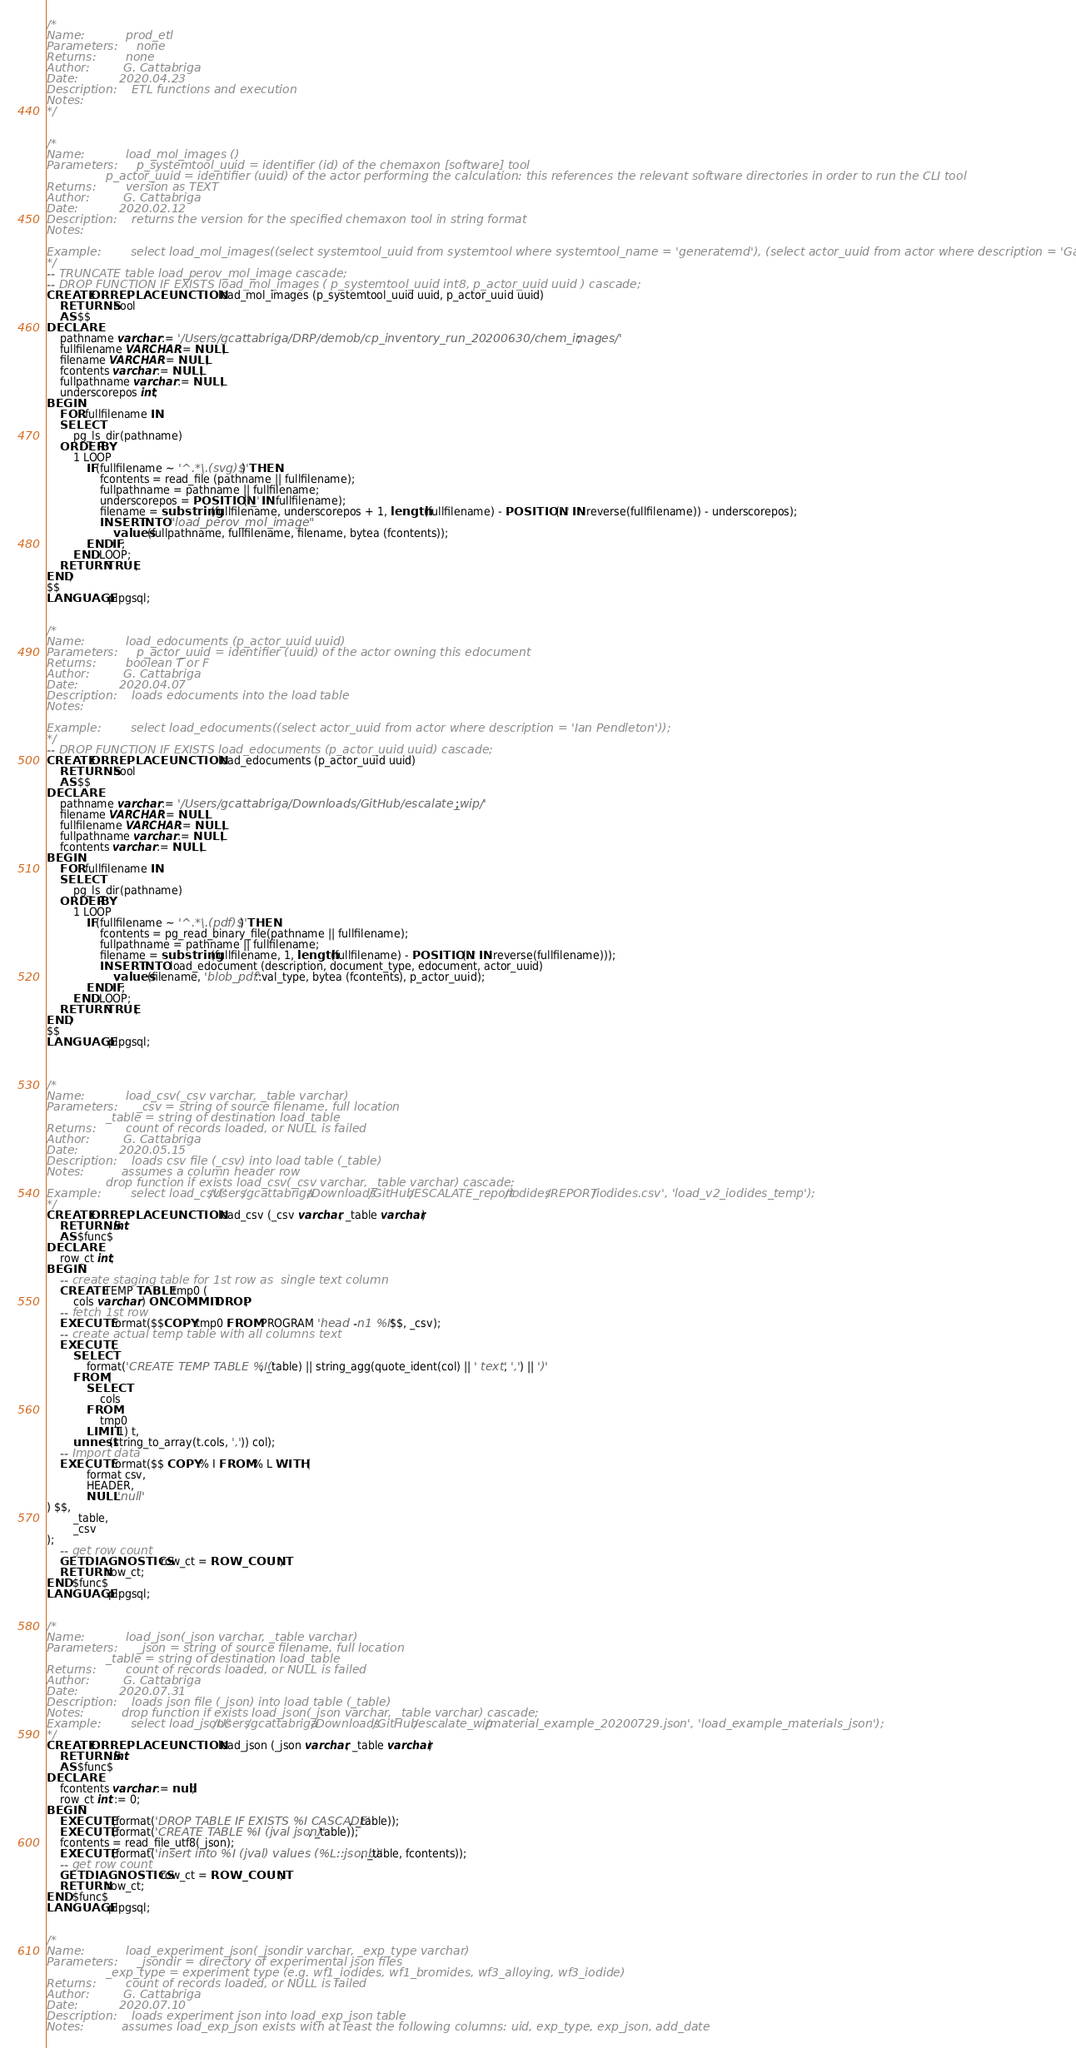Convert code to text. <code><loc_0><loc_0><loc_500><loc_500><_SQL_>/*
Name:			prod_etl
Parameters:		none
Returns:		none
Author:			G. Cattabriga
Date:			2020.04.23
Description:	ETL functions and execution
Notes:											
*/


/*
Name:			load_mol_images ()
Parameters:		p_systemtool_uuid = identifier (id) of the chemaxon [software] tool
				p_actor_uuid = identifier (uuid) of the actor performing the calculation: this references the relevant software directories in order to run the CLI tool
Returns:		version as TEXT
Author:			G. Cattabriga
Date:			2020.02.12
Description:	returns the version for the specified chemaxon tool in string format 
Notes:				
							
Example:		select load_mol_images((select systemtool_uuid from systemtool where systemtool_name = 'generatemd'), (select actor_uuid from actor where description = 'Gary Cattabriga'));
*/
-- TRUNCATE table load_perov_mol_image cascade;
-- DROP FUNCTION IF EXISTS load_mol_images ( p_systemtool_uuid int8, p_actor_uuid uuid ) cascade;
CREATE OR REPLACE FUNCTION load_mol_images (p_systemtool_uuid uuid, p_actor_uuid uuid)
	RETURNS bool
	AS $$
DECLARE
	pathname varchar := '/Users/gcattabriga/DRP/demob/cp_inventory_run_20200630/chem_images/';
	fullfilename VARCHAR := NULL;
	filename VARCHAR := NULL;
	fcontents varchar := NULL;
	fullpathname varchar := NULL;
	underscorepos int;
BEGIN
	FOR fullfilename IN
	SELECT
		pg_ls_dir(pathname)
	ORDER BY
		1 LOOP
			IF(fullfilename ~ '^.*\.(svg)$') THEN
				fcontents = read_file (pathname || fullfilename);
				fullpathname = pathname || fullfilename;
				underscorepos = POSITION('_' IN fullfilename);
				filename = substring(fullfilename, underscorepos + 1, length(fullfilename) - POSITION('.' IN reverse(fullfilename)) - underscorepos);
				INSERT INTO "load_perov_mol_image"
					values(fullpathname, fullfilename, filename, bytea (fcontents));
			END IF;
		END LOOP;
	RETURN TRUE;
END;
$$
LANGUAGE plpgsql;


/*
Name:			load_edocuments (p_actor_uuid uuid)
Parameters:		p_actor_uuid = identifier (uuid) of the actor owning this edocument
Returns:		boolean T or F
Author:			G. Cattabriga
Date:			2020.04.07
Description:	loads edocuments into the load table 
Notes:				
							
Example:		select load_edocuments((select actor_uuid from actor where description = 'Ian Pendleton'));
*/
-- DROP FUNCTION IF EXISTS load_edocuments (p_actor_uuid uuid) cascade;
CREATE OR REPLACE FUNCTION load_edocuments (p_actor_uuid uuid)
	RETURNS bool
	AS $$
DECLARE
	pathname varchar := '/Users/gcattabriga/Downloads/GitHub/escalate_wip/';
	filename VARCHAR := NULL;
	fullfilename VARCHAR := NULL;
	fullpathname varchar := NULL;
	fcontents varchar := NULL;
BEGIN
	FOR fullfilename IN
	SELECT
		pg_ls_dir(pathname)
	ORDER BY
		1 LOOP
			IF(fullfilename ~ '^.*\.(pdf)$') THEN
				fcontents = pg_read_binary_file(pathname || fullfilename);
				fullpathname = pathname || fullfilename;
				filename = substring(fullfilename, 1, length(fullfilename) - POSITION('.' IN reverse(fullfilename)));
				INSERT INTO load_edocument (description, document_type, edocument, actor_uuid)
					values(filename, 'blob_pdf'::val_type, bytea (fcontents), p_actor_uuid);
			END IF;
		END LOOP;
	RETURN TRUE;
END;
$$
LANGUAGE plpgsql;



/*
Name:			load_csv(_csv varchar, _table varchar)
Parameters:		_csv = string of source filename, full location
				_table = string of destination load_table
Returns:		count of records loaded, or NULL is failed
Author:			G. Cattabriga
Date:			2020.05.15
Description:	loads csv file (_csv) into load table (_table) 
Notes:			assumes a column header row
				drop function if exists load_csv(_csv varchar, _table varchar) cascade;
Example:		select load_csv('/Users/gcattabriga/Downloads/GitHub/ESCALATE_report/iodides/REPORT/iodides.csv', 'load_v2_iodides_temp');
*/
CREATE OR REPLACE FUNCTION load_csv (_csv varchar, _table varchar)
	RETURNS int
	AS $func$
DECLARE
	row_ct int;
BEGIN
	-- create staging table for 1st row as  single text column
	CREATE TEMP TABLE tmp0 (
		cols varchar ) ON COMMIT DROP;
	-- fetch 1st row
	EXECUTE format($$COPY tmp0 FROM PROGRAM 'head -n1 %I' $$, _csv);
	-- create actual temp table with all columns text
	EXECUTE (
		SELECT
			format('CREATE TEMP TABLE %I(', _table) || string_agg(quote_ident(col) || ' text', ',') || ')'
		FROM (
			SELECT
				cols
			FROM
				tmp0
			LIMIT 1) t,
		unnest(string_to_array(t.cols, ',')) col);
	-- Import data
	EXECUTE format($$ COPY % I FROM % L WITH (
			format csv,
			HEADER,
			NULL 'null'
) $$,
		_table,
		_csv
);
	-- get row count
	GET DIAGNOSTICS row_ct = ROW_COUNT;
	RETURN row_ct;
END $func$
LANGUAGE plpgsql;


/*
Name:			load_json(_json varchar, _table varchar)
Parameters:		_json = string of source filename, full location
				_table = string of destination load_table
Returns:		count of records loaded, or NULL is failed
Author:			G. Cattabriga
Date:			2020.07.31
Description:	loads json file (_json) into load table (_table) 
Notes:			drop function if exists load_json(_json varchar, _table varchar) cascade;
Example:		select load_json('/Users/gcattabriga/Downloads/GitHub/escalate_wip/material_example_20200729.json', 'load_example_materials_json');
*/
CREATE OR REPLACE FUNCTION load_json (_json varchar, _table varchar)
	RETURNS int
	AS $func$
DECLARE
	fcontents varchar := null;
	row_ct int := 0;
BEGIN
	EXECUTE (format('DROP TABLE IF EXISTS %I CASCADE', _table));
	EXECUTE (format('CREATE TABLE %I (jval json)', _table));
	fcontents = read_file_utf8(_json);
	EXECUTE (format('insert into %I (jval) values (%L::jsonb)', _table, fcontents));
	-- get row count
	GET DIAGNOSTICS row_ct = ROW_COUNT;
	RETURN row_ct;
END $func$
LANGUAGE plpgsql;


/*
Name:			load_experiment_json(_jsondir varchar, _exp_type varchar)
Parameters:		_jsondir = directory of experimental json files
				_exp_type = experiment type (e.g. wf1_iodides, wf1_bromides, wf3_alloying, wf3_iodide) 
Returns:		count of records loaded, or NULL is failed
Author:			G. Cattabriga
Date:			2020.07.10
Description:	loads experiment json into load_exp_json table 
Notes:			assumes load_exp_json exists with at least the following columns: uid, exp_type, exp_json, add_date </code> 